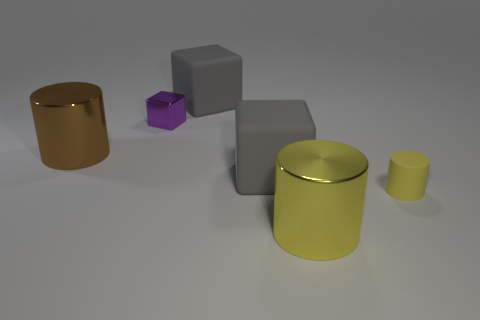Are there any patterns or symmetry in how the objects are arranged? The objects are placed in a somewhat asymmetrical fashion without clear patterns, but the staggered heights and the spacing between them might suggest an attempt at balanced visual composition. 